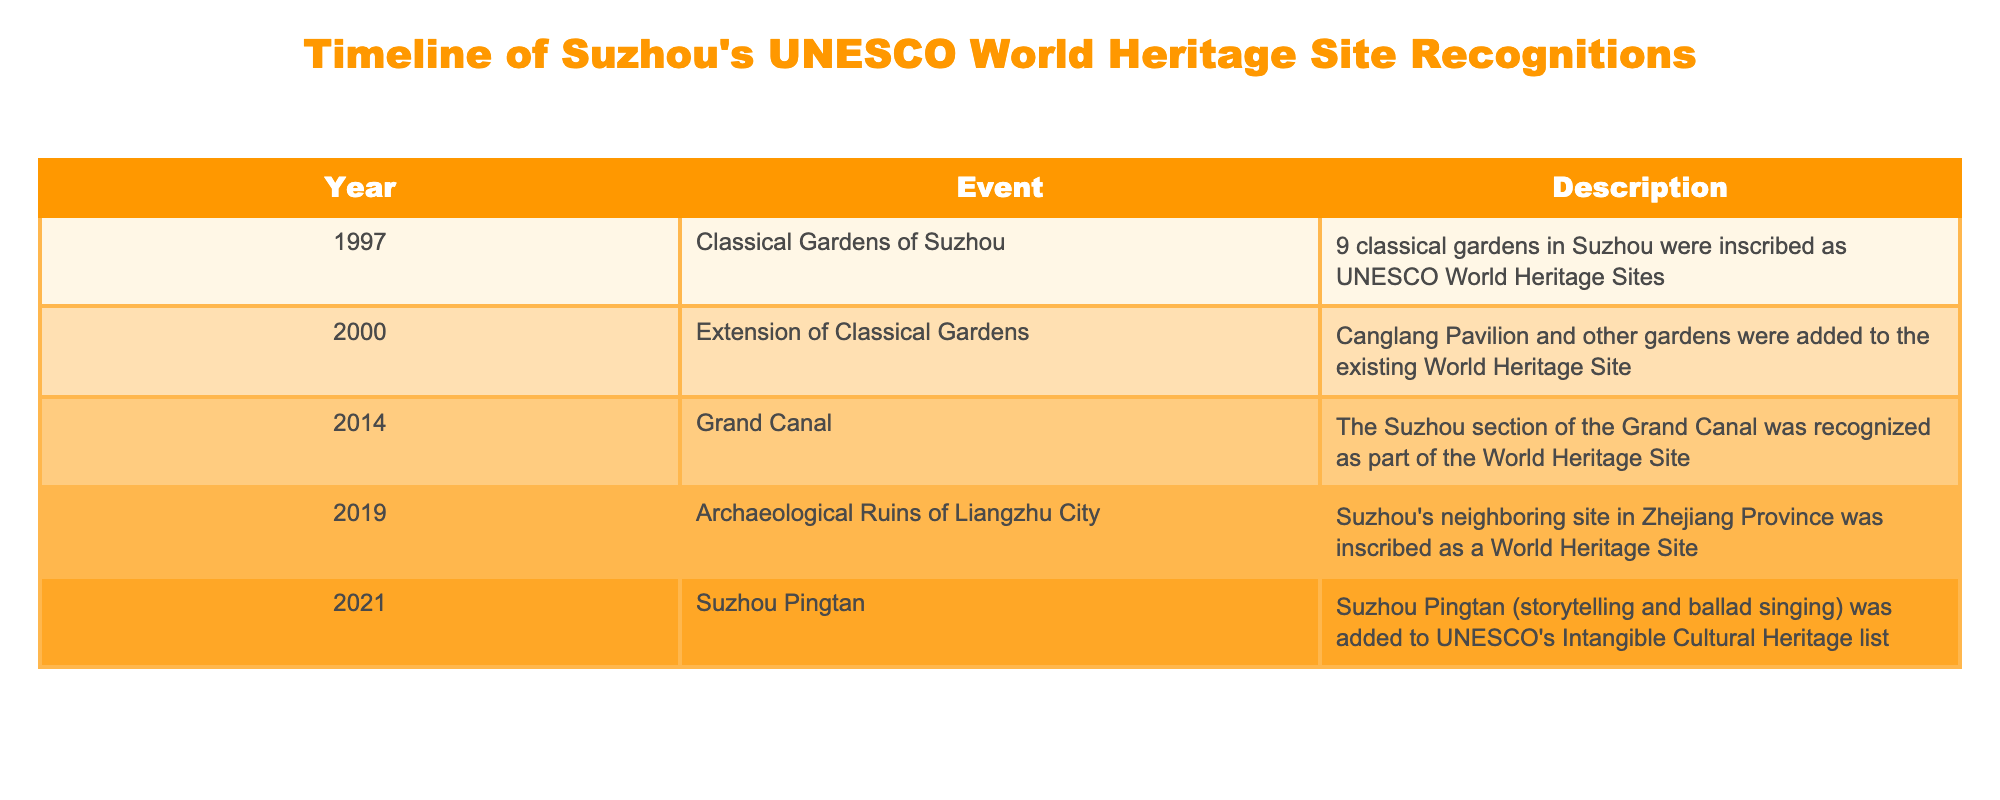What year were the Classical Gardens of Suzhou inscribed as UNESCO World Heritage Sites? The table lists "1997" as the year when "Classical Gardens of Suzhou" were recognized.
Answer: 1997 How many events related to UNESCO recognitions occurred in 2014? According to the table, there is only one event listed for 2014, which is the recognition of the Suzhou section of the Grand Canal.
Answer: 1 Did any event related to Suzhou's UNESCO status occur in 2021? Yes, the table indicates that in 2021, Suzhou Pingtan was added to UNESCO's Intangible Cultural Heritage list.
Answer: Yes What is the most recent event in the timeline? Looking at the years provided in the table, the most recent event is in 2021, which relates to Suzhou Pingtan being recognized.
Answer: 2021 How many total events are listed in the table before 2020? By examining the table, we see four events listed: in 1997, 2000, 2014, and 2019. Thus, the total is four events.
Answer: 4 Was the Grand Canal recognized as a World Heritage Site before or after the Classical Gardens? The Grand Canal's recognition in 2014 occurred after the Classical Gardens were inscribed in 1997. This is gleaned directly from comparing the years listed in the table.
Answer: After How many years passed between the inscription of the Classical Gardens and the addition of the Grand Canal? The Classical Gardens were inscribed in 1997, and the Grand Canal was added in 2014. The difference is 2014 - 1997 = 17 years. Thus, it took 17 years from one event to the other.
Answer: 17 Is the recognition of the Archaeological Ruins of Liangzhu City directly related to Suzhou? The table states that the Archaeological Ruins of Liangzhu City was inscribed as a World Heritage Site in 2019, but it emphasizes that it is in Zhejiang Province, neighboring Suzhou. Thus, it is not directly a Suzhou site.
Answer: No How many UNESCO listings involve intangible cultural heritage? The only listing specifically mentioned as Intangible Cultural Heritage is Suzhou Pingtan in 2021, making it one event related to intangible heritage.
Answer: 1 